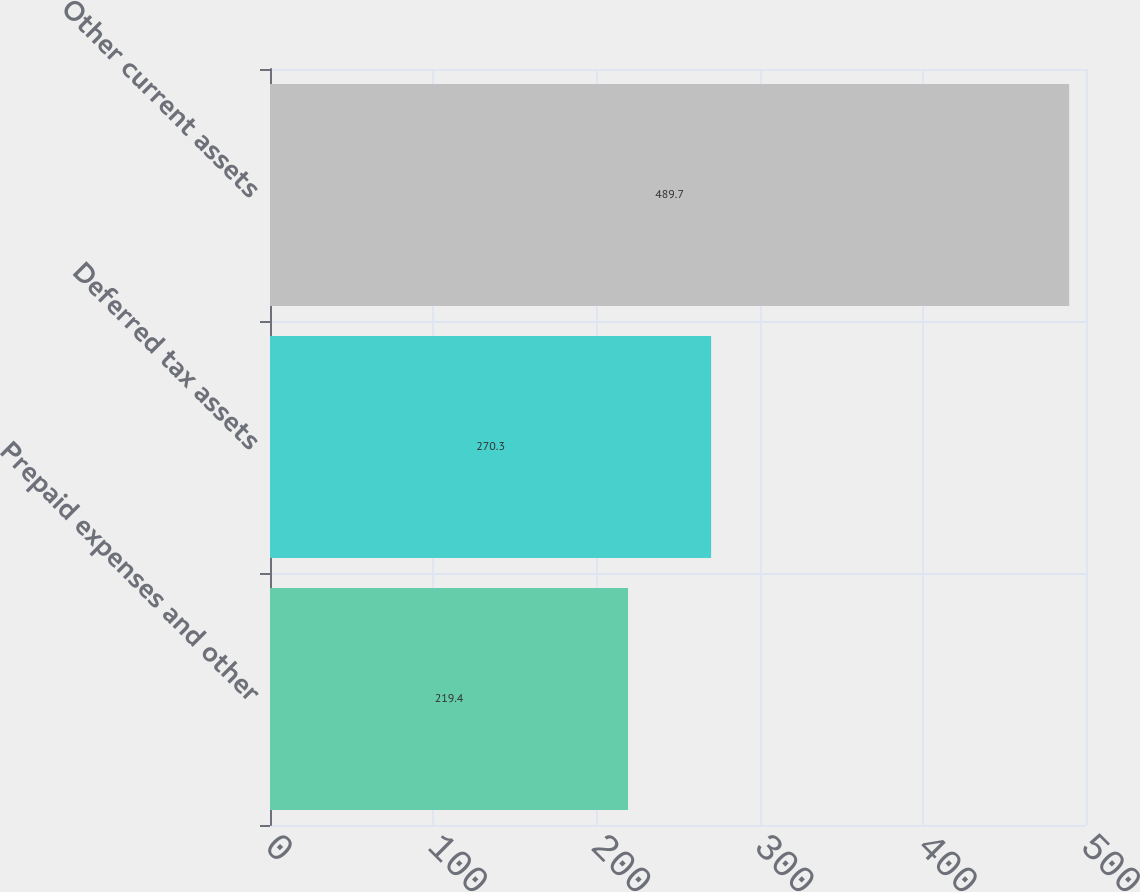Convert chart. <chart><loc_0><loc_0><loc_500><loc_500><bar_chart><fcel>Prepaid expenses and other<fcel>Deferred tax assets<fcel>Other current assets<nl><fcel>219.4<fcel>270.3<fcel>489.7<nl></chart> 